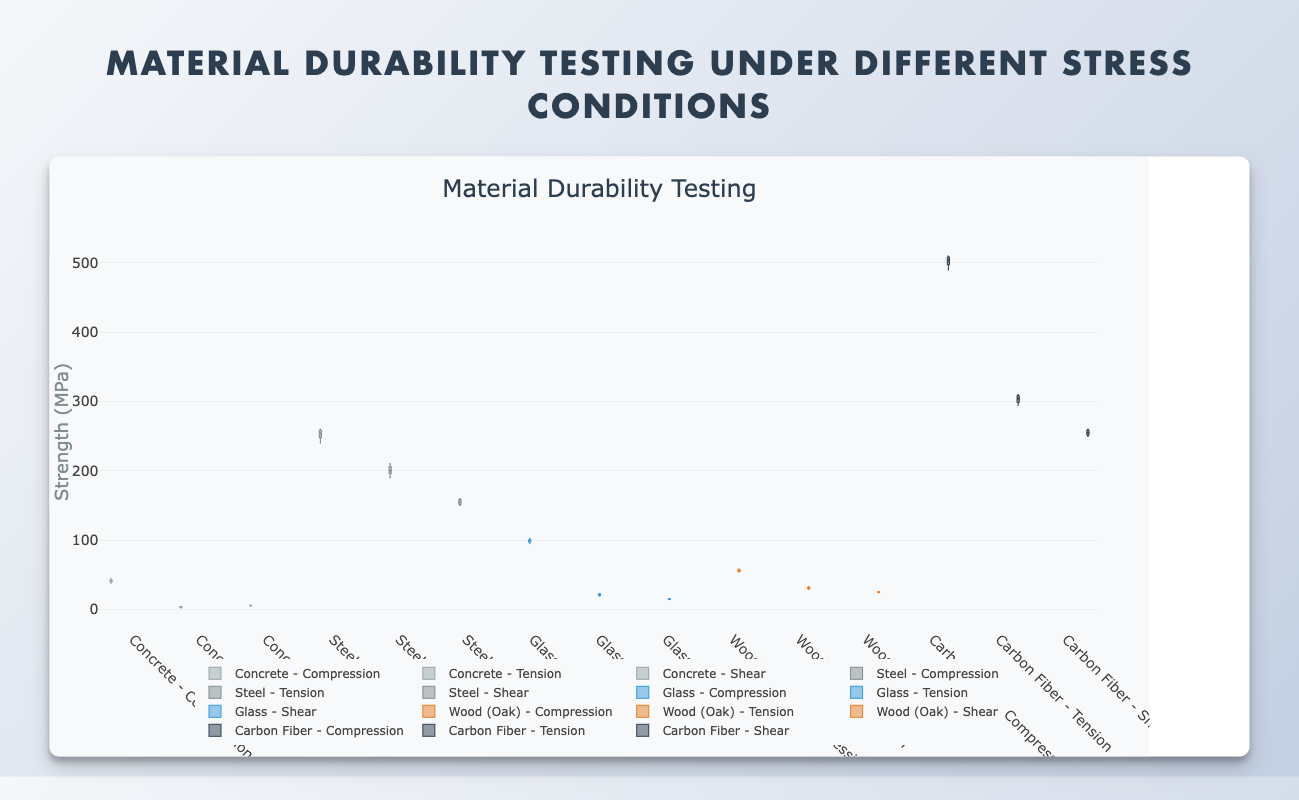What material has the highest median compression strength? To determine the material with the highest median compression strength, look at the horizontal line inside each box plot for "Compression". Carbon Fiber has the highest median.
Answer: Carbon Fiber Which material shows the most variability in shear strength? The variability in shear strength is indicated by the height of the box (interquartile range) and the length of the whiskers. Steel shows the most variability in shear strength.
Answer: Steel What is the median compression strength of Concrete? Locate the box plot for Concrete under "Compression" and check the horizontal line inside the box. The median compression strength of Concrete is 41.
Answer: 41 How does the interquartile range (IQR) for tension strength in Glass compare to that in Wood (Oak)? The IQR can be determined by the height of the box in each respective box plot for Glass and Wood (Oak) under "Tension". Glass has a larger IQR (difference between 25th and 75th percentiles) than Wood (Oak).
Answer: Glass has a larger IQR Which material under tension stress exhibits outliers, and what are they? Identify the box plots under "Tension" and look for points outside the box-and-whisker range. Glass exhibits an outlier at approximately 23.
Answer: Glass, approximately 23 What is the range of shear strength for Carbon Fiber? The range is determined by the difference between the maximum and minimum whisker points in the "Shear" box plot. The range for Carbon Fiber's shear strength is around 250 to 260.
Answer: 250 to 260 Which material has a higher median shear strength, Steel or Wood (Oak)? Compare the horizontal lines inside the "Shear" box plots for both Steel and Wood (Oak). Steel has a higher median shear strength.
Answer: Steel Is the median tension strength of Carbon Fiber greater than its median shear strength? Compare the horizontal lines inside the box plots for Carbon Fiber in "Tension" and "Shear". The median tension strength of Carbon Fiber is not greater than its shear strength.
Answer: No What does the median value represent in these box plots? The median value represents the middle point of the data when it is sorted in ascending order; it divides the dataset into two equal halves. This is depicted by the horizontal line inside the box in each plot.
Answer: The middle point of the data Which material shows the smallest range in compression strength values? The range is determined by the difference between the maximum and minimum whisker points in the "Compression" box plots. Concrete shows the smallest range in compression strength values.
Answer: Concrete 